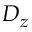Convert formula to latex. <formula><loc_0><loc_0><loc_500><loc_500>D _ { z }</formula> 